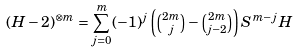<formula> <loc_0><loc_0><loc_500><loc_500>( H - 2 ) ^ { \otimes m } = \sum _ { j = 0 } ^ { m } ( - 1 ) ^ { j } \left ( \tbinom { 2 m } { j } - \tbinom { 2 m } { j - 2 } \right ) S ^ { m - j } H</formula> 